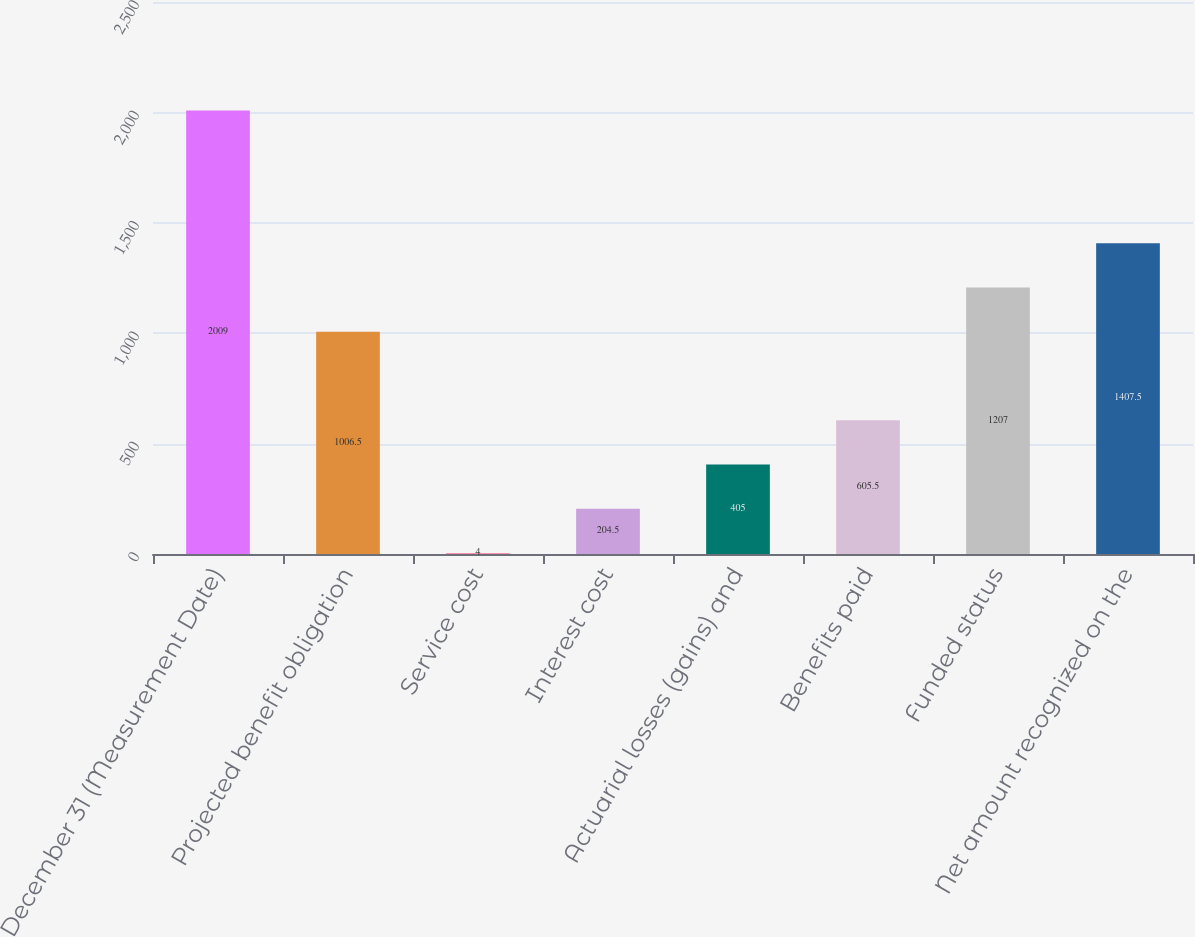<chart> <loc_0><loc_0><loc_500><loc_500><bar_chart><fcel>December 31 (Measurement Date)<fcel>Projected benefit obligation<fcel>Service cost<fcel>Interest cost<fcel>Actuarial losses (gains) and<fcel>Benefits paid<fcel>Funded status<fcel>Net amount recognized on the<nl><fcel>2009<fcel>1006.5<fcel>4<fcel>204.5<fcel>405<fcel>605.5<fcel>1207<fcel>1407.5<nl></chart> 